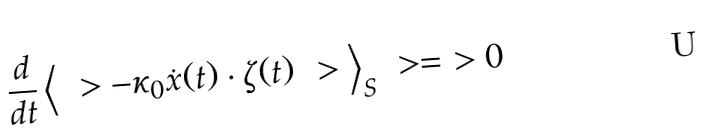Convert formula to latex. <formula><loc_0><loc_0><loc_500><loc_500>\frac { d } { d t } \, \Big < \ > - \kappa _ { 0 } \dot { x } ( t ) \cdot \zeta ( t ) \ > \Big > _ { S } \ > = \ > 0</formula> 